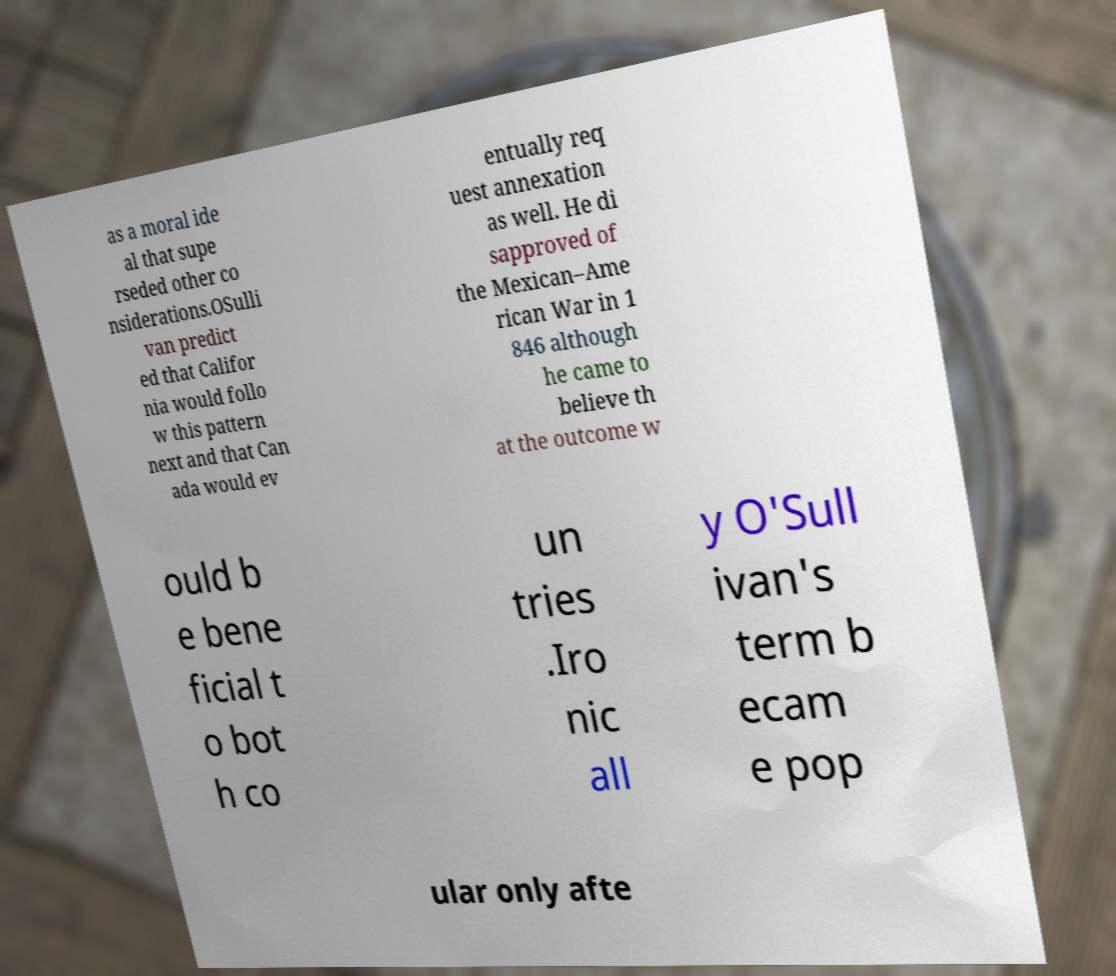I need the written content from this picture converted into text. Can you do that? as a moral ide al that supe rseded other co nsiderations.OSulli van predict ed that Califor nia would follo w this pattern next and that Can ada would ev entually req uest annexation as well. He di sapproved of the Mexican–Ame rican War in 1 846 although he came to believe th at the outcome w ould b e bene ficial t o bot h co un tries .Iro nic all y O'Sull ivan's term b ecam e pop ular only afte 